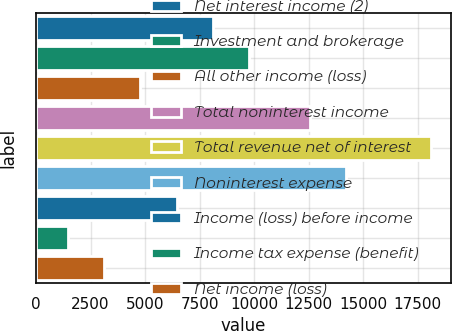Convert chart to OTSL. <chart><loc_0><loc_0><loc_500><loc_500><bar_chart><fcel>Net interest income (2)<fcel>Investment and brokerage<fcel>All other income (loss)<fcel>Total noninterest income<fcel>Total revenue net of interest<fcel>Noninterest expense<fcel>Income (loss) before income<fcel>Income tax expense (benefit)<fcel>Net income (loss)<nl><fcel>8116.8<fcel>9784.5<fcel>4781.4<fcel>12559<fcel>18123<fcel>14226.7<fcel>6449.1<fcel>1446<fcel>3113.7<nl></chart> 